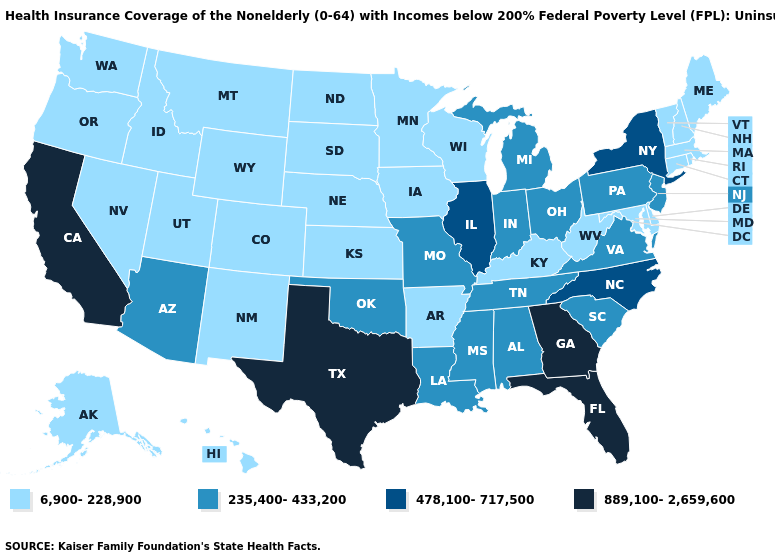What is the highest value in the USA?
Short answer required. 889,100-2,659,600. What is the highest value in the Northeast ?
Keep it brief. 478,100-717,500. Does the first symbol in the legend represent the smallest category?
Keep it brief. Yes. What is the value of South Carolina?
Give a very brief answer. 235,400-433,200. What is the value of Florida?
Write a very short answer. 889,100-2,659,600. Does New Hampshire have the same value as Mississippi?
Be succinct. No. Among the states that border New Mexico , does Texas have the highest value?
Concise answer only. Yes. What is the value of Colorado?
Short answer required. 6,900-228,900. Among the states that border Oregon , does Washington have the lowest value?
Write a very short answer. Yes. Name the states that have a value in the range 478,100-717,500?
Short answer required. Illinois, New York, North Carolina. Does the first symbol in the legend represent the smallest category?
Short answer required. Yes. What is the value of Washington?
Give a very brief answer. 6,900-228,900. Among the states that border Virginia , does Kentucky have the lowest value?
Concise answer only. Yes. Name the states that have a value in the range 235,400-433,200?
Concise answer only. Alabama, Arizona, Indiana, Louisiana, Michigan, Mississippi, Missouri, New Jersey, Ohio, Oklahoma, Pennsylvania, South Carolina, Tennessee, Virginia. How many symbols are there in the legend?
Give a very brief answer. 4. 